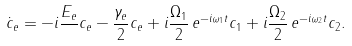Convert formula to latex. <formula><loc_0><loc_0><loc_500><loc_500>\dot { c } _ { e } = - i \frac { E _ { e } } { } c _ { e } - \frac { \gamma _ { e } } { 2 } c _ { e } + i \frac { \Omega _ { 1 } } { 2 } \, e ^ { - i \omega _ { 1 } t } c _ { 1 } + i \frac { \Omega _ { 2 } } { 2 } \, e ^ { - i \omega _ { 2 } t } c _ { 2 } .</formula> 